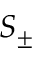Convert formula to latex. <formula><loc_0><loc_0><loc_500><loc_500>S _ { \pm }</formula> 